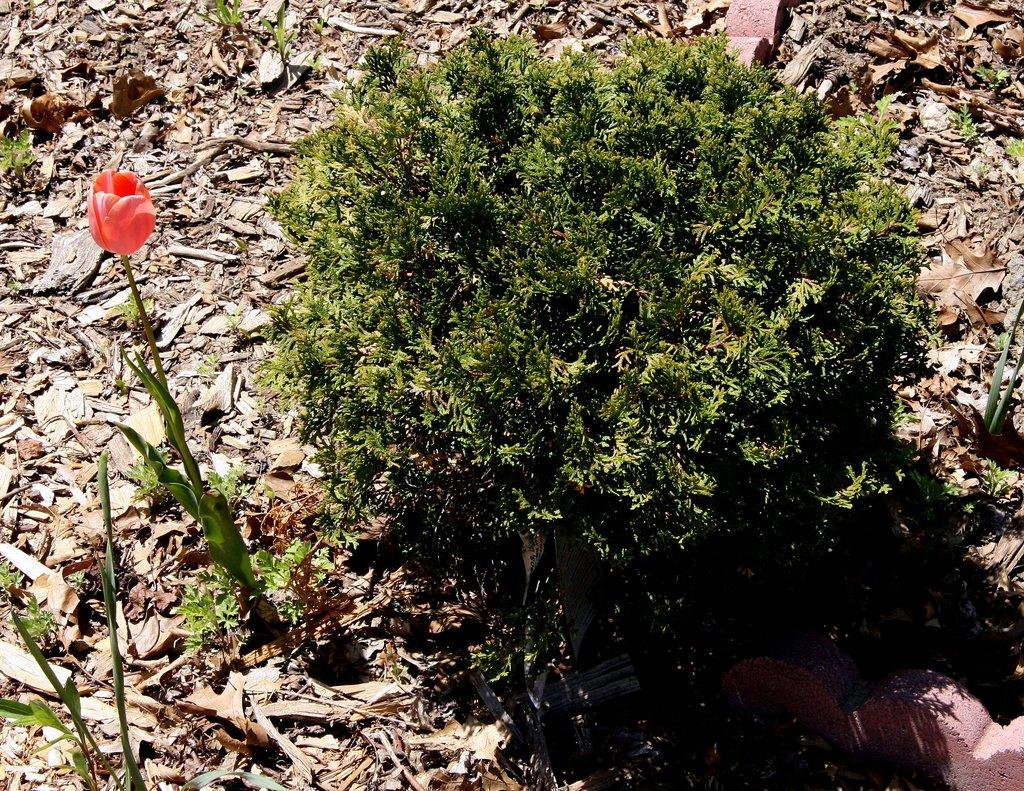What type of plant can be seen in the image? There is a flower plant in the image. Are there any other plants in the image? Yes, there is another plant beside the flower plant. What can be observed around the plants in the image? There are many dry leaves around the plants. What type of bag is hanging on the appliance in the image? There is no bag or appliance present in the image; it only features plants and dry leaves. 